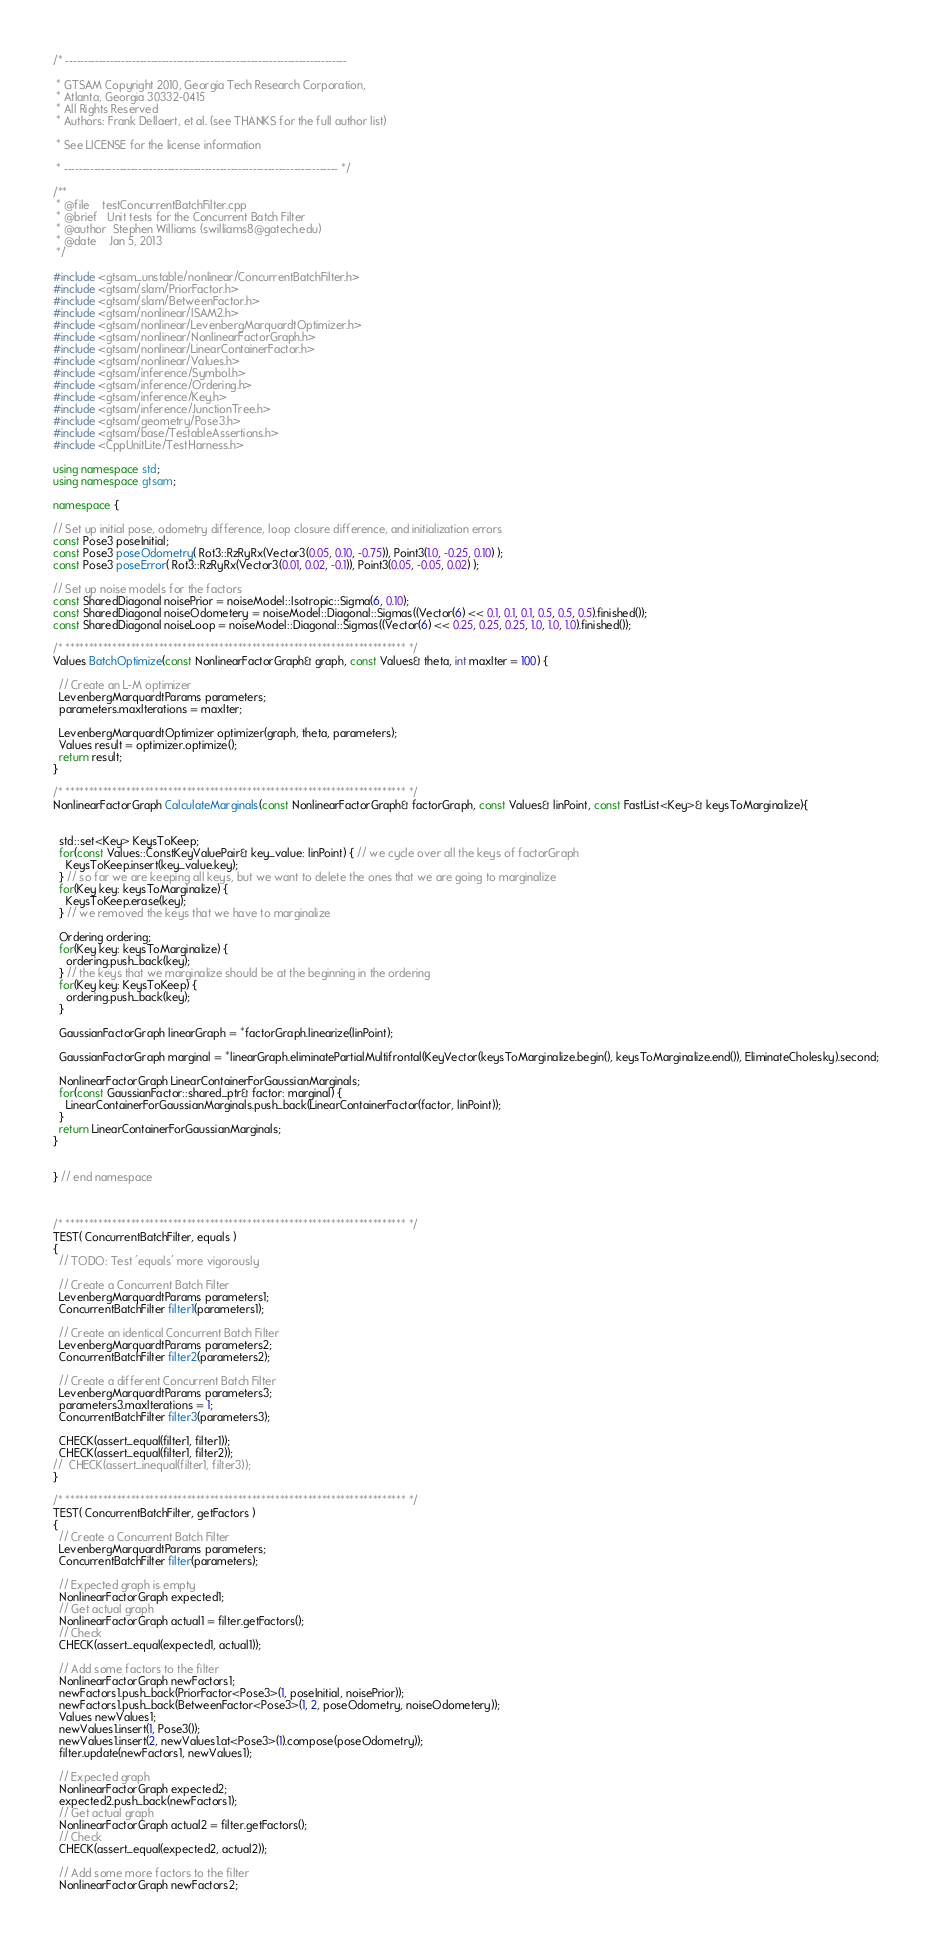<code> <loc_0><loc_0><loc_500><loc_500><_C++_>/* ----------------------------------------------------------------------------

 * GTSAM Copyright 2010, Georgia Tech Research Corporation,
 * Atlanta, Georgia 30332-0415
 * All Rights Reserved
 * Authors: Frank Dellaert, et al. (see THANKS for the full author list)

 * See LICENSE for the license information

 * -------------------------------------------------------------------------- */

/**
 * @file    testConcurrentBatchFilter.cpp
 * @brief   Unit tests for the Concurrent Batch Filter
 * @author  Stephen Williams (swilliams8@gatech.edu)
 * @date    Jan 5, 2013
 */

#include <gtsam_unstable/nonlinear/ConcurrentBatchFilter.h>
#include <gtsam/slam/PriorFactor.h>
#include <gtsam/slam/BetweenFactor.h>
#include <gtsam/nonlinear/ISAM2.h>
#include <gtsam/nonlinear/LevenbergMarquardtOptimizer.h>
#include <gtsam/nonlinear/NonlinearFactorGraph.h>
#include <gtsam/nonlinear/LinearContainerFactor.h>
#include <gtsam/nonlinear/Values.h>
#include <gtsam/inference/Symbol.h>
#include <gtsam/inference/Ordering.h>
#include <gtsam/inference/Key.h>
#include <gtsam/inference/JunctionTree.h>
#include <gtsam/geometry/Pose3.h>
#include <gtsam/base/TestableAssertions.h>
#include <CppUnitLite/TestHarness.h>

using namespace std;
using namespace gtsam;

namespace {

// Set up initial pose, odometry difference, loop closure difference, and initialization errors
const Pose3 poseInitial;
const Pose3 poseOdometry( Rot3::RzRyRx(Vector3(0.05, 0.10, -0.75)), Point3(1.0, -0.25, 0.10) );
const Pose3 poseError( Rot3::RzRyRx(Vector3(0.01, 0.02, -0.1)), Point3(0.05, -0.05, 0.02) );

// Set up noise models for the factors
const SharedDiagonal noisePrior = noiseModel::Isotropic::Sigma(6, 0.10);
const SharedDiagonal noiseOdometery = noiseModel::Diagonal::Sigmas((Vector(6) << 0.1, 0.1, 0.1, 0.5, 0.5, 0.5).finished());
const SharedDiagonal noiseLoop = noiseModel::Diagonal::Sigmas((Vector(6) << 0.25, 0.25, 0.25, 1.0, 1.0, 1.0).finished());

/* ************************************************************************* */
Values BatchOptimize(const NonlinearFactorGraph& graph, const Values& theta, int maxIter = 100) {

  // Create an L-M optimizer
  LevenbergMarquardtParams parameters;
  parameters.maxIterations = maxIter;

  LevenbergMarquardtOptimizer optimizer(graph, theta, parameters);
  Values result = optimizer.optimize();
  return result;
}

/* ************************************************************************* */
NonlinearFactorGraph CalculateMarginals(const NonlinearFactorGraph& factorGraph, const Values& linPoint, const FastList<Key>& keysToMarginalize){


  std::set<Key> KeysToKeep;
  for(const Values::ConstKeyValuePair& key_value: linPoint) { // we cycle over all the keys of factorGraph
    KeysToKeep.insert(key_value.key);
  } // so far we are keeping all keys, but we want to delete the ones that we are going to marginalize
  for(Key key: keysToMarginalize) {
    KeysToKeep.erase(key);
  } // we removed the keys that we have to marginalize

  Ordering ordering;
  for(Key key: keysToMarginalize) {
    ordering.push_back(key);
  } // the keys that we marginalize should be at the beginning in the ordering
  for(Key key: KeysToKeep) {
    ordering.push_back(key);
  }

  GaussianFactorGraph linearGraph = *factorGraph.linearize(linPoint);

  GaussianFactorGraph marginal = *linearGraph.eliminatePartialMultifrontal(KeyVector(keysToMarginalize.begin(), keysToMarginalize.end()), EliminateCholesky).second;

  NonlinearFactorGraph LinearContainerForGaussianMarginals;
  for(const GaussianFactor::shared_ptr& factor: marginal) {
    LinearContainerForGaussianMarginals.push_back(LinearContainerFactor(factor, linPoint));
  }
  return LinearContainerForGaussianMarginals;
}


} // end namespace



/* ************************************************************************* */
TEST( ConcurrentBatchFilter, equals )
{
  // TODO: Test 'equals' more vigorously

  // Create a Concurrent Batch Filter
  LevenbergMarquardtParams parameters1;
  ConcurrentBatchFilter filter1(parameters1);

  // Create an identical Concurrent Batch Filter
  LevenbergMarquardtParams parameters2;
  ConcurrentBatchFilter filter2(parameters2);

  // Create a different Concurrent Batch Filter
  LevenbergMarquardtParams parameters3;
  parameters3.maxIterations = 1;
  ConcurrentBatchFilter filter3(parameters3);

  CHECK(assert_equal(filter1, filter1));
  CHECK(assert_equal(filter1, filter2));
//  CHECK(assert_inequal(filter1, filter3));
}

/* ************************************************************************* */
TEST( ConcurrentBatchFilter, getFactors )
{
  // Create a Concurrent Batch Filter
  LevenbergMarquardtParams parameters;
  ConcurrentBatchFilter filter(parameters);

  // Expected graph is empty
  NonlinearFactorGraph expected1;
  // Get actual graph
  NonlinearFactorGraph actual1 = filter.getFactors();
  // Check
  CHECK(assert_equal(expected1, actual1));

  // Add some factors to the filter
  NonlinearFactorGraph newFactors1;
  newFactors1.push_back(PriorFactor<Pose3>(1, poseInitial, noisePrior));
  newFactors1.push_back(BetweenFactor<Pose3>(1, 2, poseOdometry, noiseOdometery));
  Values newValues1;
  newValues1.insert(1, Pose3());
  newValues1.insert(2, newValues1.at<Pose3>(1).compose(poseOdometry));
  filter.update(newFactors1, newValues1);

  // Expected graph
  NonlinearFactorGraph expected2;
  expected2.push_back(newFactors1);
  // Get actual graph
  NonlinearFactorGraph actual2 = filter.getFactors();
  // Check
  CHECK(assert_equal(expected2, actual2));

  // Add some more factors to the filter
  NonlinearFactorGraph newFactors2;</code> 